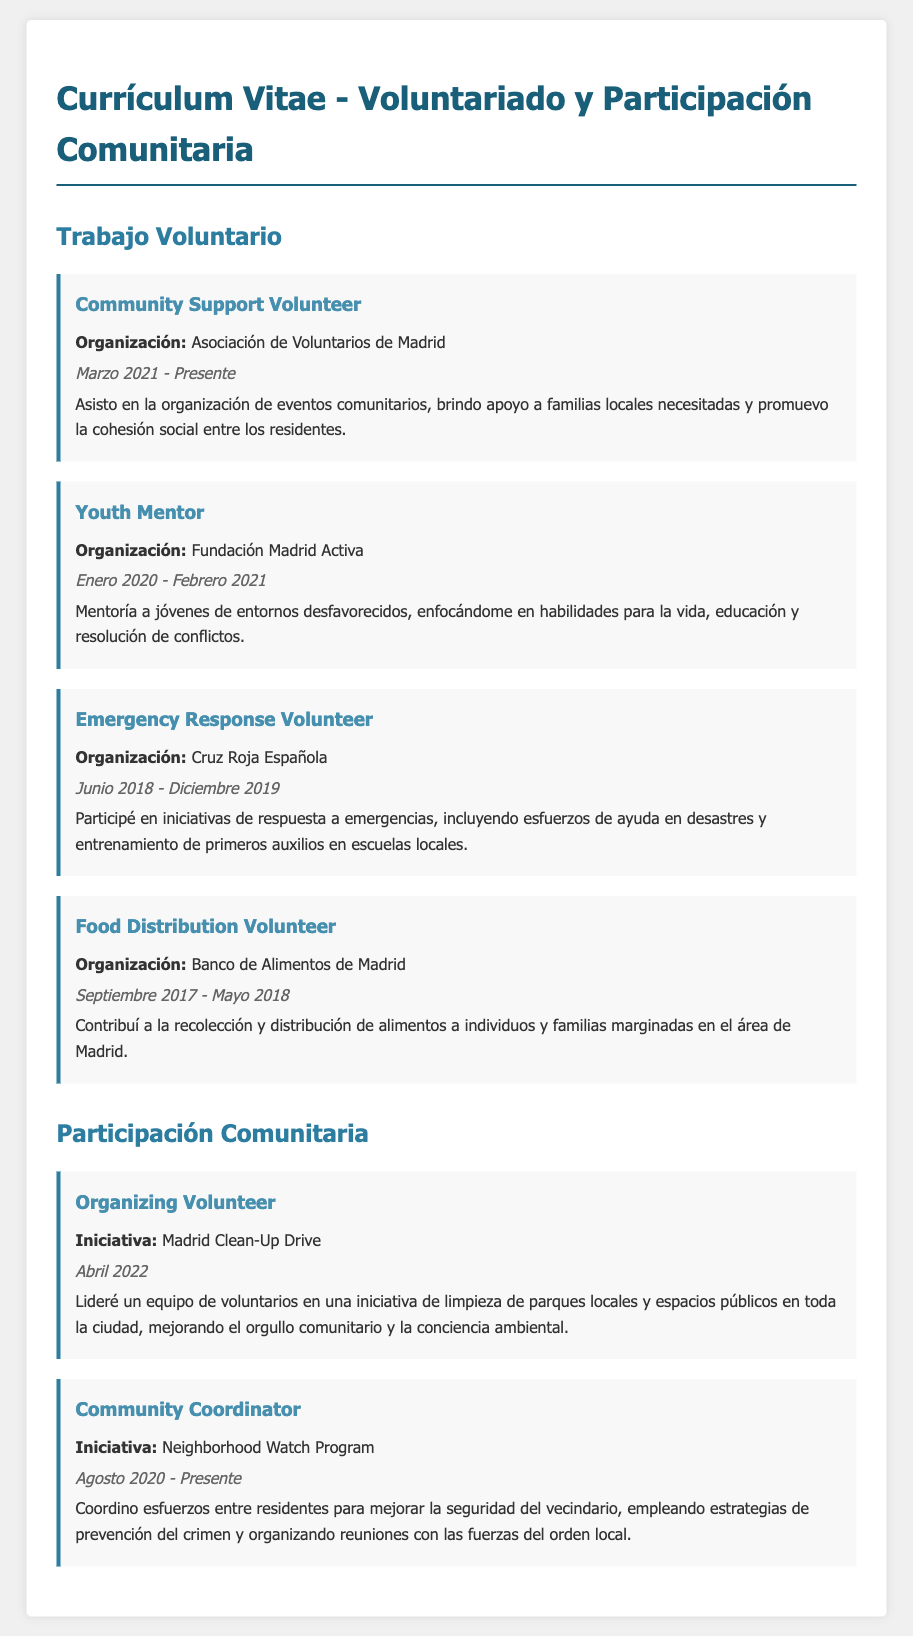¿Qué organización está asociada con el trabajo voluntario actual? La organización mencionada en el trabajo voluntario actual es la Asociación de Voluntarios de Madrid.
Answer: Asociación de Voluntarios de Madrid ¿Cuándo comenzó a trabajar como Mentor Juvenil? La fecha de inicio de la labor como Mentor Juvenil es en enero de 2020.
Answer: Enero 2020 ¿Cuál fue la duración del trabajo como voluntario en Cruz Roja Española? La duración del trabajo como voluntario en Cruz Roja Española fue de junio de 2018 a diciembre de 2019.
Answer: Junio 2018 - Diciembre 2019 ¿Qué tipo de iniciativas organiza como Coordinador Comunitario? Como Coordinador Comunitario, organiza esfuerzos para mejorar la seguridad del vecindario.
Answer: Seguridad del vecindario ¿Cuál fue el enfoque de la actividad en el Madrid Clean-Up Drive? La actividad del Madrid Clean-Up Drive se centró en limpiar parques locales y espacios públicos.
Answer: Limpiar parques locales y espacios públicos ¿Cuál es la función principal del apoyo brindado en la Asociación de Voluntarios de Madrid? El apoyo brindado en la Asociación de Voluntarios de Madrid se centra en la organización de eventos comunitarios.
Answer: Organización de eventos comunitarios ¿Cuál es la fecha de finalización del trabajo en el Banco de Alimentos de Madrid? La fecha de finalización del trabajo en el Banco de Alimentos de Madrid es mayo de 2018.
Answer: Mayo 2018 ¿Qué tipo de jóvenes estuvo mentorando? Estuvo mentorando a jóvenes de entornos desfavorecidos.
Answer: Entornos desfavorecidos 